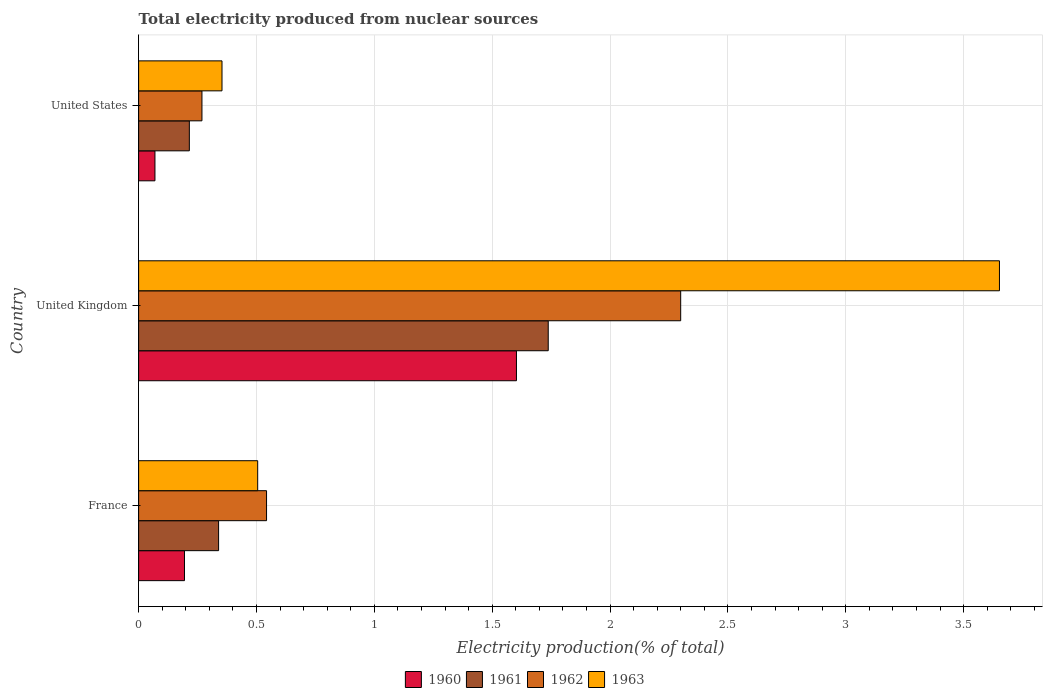Are the number of bars per tick equal to the number of legend labels?
Ensure brevity in your answer.  Yes. Are the number of bars on each tick of the Y-axis equal?
Provide a short and direct response. Yes. How many bars are there on the 3rd tick from the top?
Offer a very short reply. 4. What is the label of the 1st group of bars from the top?
Give a very brief answer. United States. In how many cases, is the number of bars for a given country not equal to the number of legend labels?
Ensure brevity in your answer.  0. What is the total electricity produced in 1962 in United Kingdom?
Give a very brief answer. 2.3. Across all countries, what is the maximum total electricity produced in 1960?
Make the answer very short. 1.6. Across all countries, what is the minimum total electricity produced in 1961?
Your response must be concise. 0.22. In which country was the total electricity produced in 1960 maximum?
Provide a short and direct response. United Kingdom. In which country was the total electricity produced in 1962 minimum?
Offer a very short reply. United States. What is the total total electricity produced in 1962 in the graph?
Give a very brief answer. 3.11. What is the difference between the total electricity produced in 1963 in United Kingdom and that in United States?
Your answer should be very brief. 3.3. What is the difference between the total electricity produced in 1963 in United States and the total electricity produced in 1961 in United Kingdom?
Offer a terse response. -1.38. What is the average total electricity produced in 1961 per country?
Your answer should be compact. 0.76. What is the difference between the total electricity produced in 1960 and total electricity produced in 1962 in France?
Your response must be concise. -0.35. What is the ratio of the total electricity produced in 1963 in France to that in United Kingdom?
Make the answer very short. 0.14. Is the total electricity produced in 1962 in United Kingdom less than that in United States?
Your response must be concise. No. What is the difference between the highest and the second highest total electricity produced in 1963?
Your answer should be compact. 3.15. What is the difference between the highest and the lowest total electricity produced in 1960?
Offer a very short reply. 1.53. Is the sum of the total electricity produced in 1962 in United Kingdom and United States greater than the maximum total electricity produced in 1960 across all countries?
Provide a succinct answer. Yes. Is it the case that in every country, the sum of the total electricity produced in 1961 and total electricity produced in 1962 is greater than the sum of total electricity produced in 1960 and total electricity produced in 1963?
Provide a short and direct response. No. What does the 1st bar from the top in United Kingdom represents?
Ensure brevity in your answer.  1963. Are all the bars in the graph horizontal?
Keep it short and to the point. Yes. How many countries are there in the graph?
Give a very brief answer. 3. What is the difference between two consecutive major ticks on the X-axis?
Your answer should be compact. 0.5. Are the values on the major ticks of X-axis written in scientific E-notation?
Offer a terse response. No. Where does the legend appear in the graph?
Keep it short and to the point. Bottom center. How are the legend labels stacked?
Ensure brevity in your answer.  Horizontal. What is the title of the graph?
Provide a succinct answer. Total electricity produced from nuclear sources. Does "1987" appear as one of the legend labels in the graph?
Offer a terse response. No. What is the label or title of the Y-axis?
Make the answer very short. Country. What is the Electricity production(% of total) of 1960 in France?
Keep it short and to the point. 0.19. What is the Electricity production(% of total) of 1961 in France?
Provide a short and direct response. 0.34. What is the Electricity production(% of total) in 1962 in France?
Your answer should be very brief. 0.54. What is the Electricity production(% of total) in 1963 in France?
Your response must be concise. 0.51. What is the Electricity production(% of total) of 1960 in United Kingdom?
Your answer should be compact. 1.6. What is the Electricity production(% of total) of 1961 in United Kingdom?
Offer a very short reply. 1.74. What is the Electricity production(% of total) of 1962 in United Kingdom?
Give a very brief answer. 2.3. What is the Electricity production(% of total) in 1963 in United Kingdom?
Offer a very short reply. 3.65. What is the Electricity production(% of total) in 1960 in United States?
Your answer should be very brief. 0.07. What is the Electricity production(% of total) in 1961 in United States?
Offer a terse response. 0.22. What is the Electricity production(% of total) in 1962 in United States?
Your response must be concise. 0.27. What is the Electricity production(% of total) of 1963 in United States?
Your answer should be very brief. 0.35. Across all countries, what is the maximum Electricity production(% of total) in 1960?
Ensure brevity in your answer.  1.6. Across all countries, what is the maximum Electricity production(% of total) of 1961?
Your response must be concise. 1.74. Across all countries, what is the maximum Electricity production(% of total) in 1962?
Your answer should be compact. 2.3. Across all countries, what is the maximum Electricity production(% of total) of 1963?
Your answer should be very brief. 3.65. Across all countries, what is the minimum Electricity production(% of total) in 1960?
Your answer should be very brief. 0.07. Across all countries, what is the minimum Electricity production(% of total) of 1961?
Make the answer very short. 0.22. Across all countries, what is the minimum Electricity production(% of total) of 1962?
Ensure brevity in your answer.  0.27. Across all countries, what is the minimum Electricity production(% of total) of 1963?
Offer a terse response. 0.35. What is the total Electricity production(% of total) in 1960 in the graph?
Provide a short and direct response. 1.87. What is the total Electricity production(% of total) in 1961 in the graph?
Offer a terse response. 2.29. What is the total Electricity production(% of total) in 1962 in the graph?
Offer a very short reply. 3.11. What is the total Electricity production(% of total) of 1963 in the graph?
Your answer should be very brief. 4.51. What is the difference between the Electricity production(% of total) of 1960 in France and that in United Kingdom?
Your answer should be compact. -1.41. What is the difference between the Electricity production(% of total) of 1961 in France and that in United Kingdom?
Your response must be concise. -1.4. What is the difference between the Electricity production(% of total) of 1962 in France and that in United Kingdom?
Your answer should be compact. -1.76. What is the difference between the Electricity production(% of total) of 1963 in France and that in United Kingdom?
Offer a terse response. -3.15. What is the difference between the Electricity production(% of total) in 1960 in France and that in United States?
Your answer should be very brief. 0.13. What is the difference between the Electricity production(% of total) of 1961 in France and that in United States?
Make the answer very short. 0.12. What is the difference between the Electricity production(% of total) in 1962 in France and that in United States?
Offer a very short reply. 0.27. What is the difference between the Electricity production(% of total) of 1963 in France and that in United States?
Keep it short and to the point. 0.15. What is the difference between the Electricity production(% of total) of 1960 in United Kingdom and that in United States?
Offer a very short reply. 1.53. What is the difference between the Electricity production(% of total) of 1961 in United Kingdom and that in United States?
Offer a very short reply. 1.52. What is the difference between the Electricity production(% of total) in 1962 in United Kingdom and that in United States?
Offer a terse response. 2.03. What is the difference between the Electricity production(% of total) in 1963 in United Kingdom and that in United States?
Keep it short and to the point. 3.3. What is the difference between the Electricity production(% of total) in 1960 in France and the Electricity production(% of total) in 1961 in United Kingdom?
Provide a short and direct response. -1.54. What is the difference between the Electricity production(% of total) in 1960 in France and the Electricity production(% of total) in 1962 in United Kingdom?
Give a very brief answer. -2.11. What is the difference between the Electricity production(% of total) in 1960 in France and the Electricity production(% of total) in 1963 in United Kingdom?
Your answer should be very brief. -3.46. What is the difference between the Electricity production(% of total) in 1961 in France and the Electricity production(% of total) in 1962 in United Kingdom?
Keep it short and to the point. -1.96. What is the difference between the Electricity production(% of total) in 1961 in France and the Electricity production(% of total) in 1963 in United Kingdom?
Provide a succinct answer. -3.31. What is the difference between the Electricity production(% of total) in 1962 in France and the Electricity production(% of total) in 1963 in United Kingdom?
Keep it short and to the point. -3.11. What is the difference between the Electricity production(% of total) of 1960 in France and the Electricity production(% of total) of 1961 in United States?
Your answer should be compact. -0.02. What is the difference between the Electricity production(% of total) in 1960 in France and the Electricity production(% of total) in 1962 in United States?
Your answer should be compact. -0.07. What is the difference between the Electricity production(% of total) in 1960 in France and the Electricity production(% of total) in 1963 in United States?
Your answer should be compact. -0.16. What is the difference between the Electricity production(% of total) of 1961 in France and the Electricity production(% of total) of 1962 in United States?
Your answer should be compact. 0.07. What is the difference between the Electricity production(% of total) in 1961 in France and the Electricity production(% of total) in 1963 in United States?
Give a very brief answer. -0.01. What is the difference between the Electricity production(% of total) in 1962 in France and the Electricity production(% of total) in 1963 in United States?
Give a very brief answer. 0.19. What is the difference between the Electricity production(% of total) in 1960 in United Kingdom and the Electricity production(% of total) in 1961 in United States?
Your answer should be compact. 1.39. What is the difference between the Electricity production(% of total) in 1960 in United Kingdom and the Electricity production(% of total) in 1962 in United States?
Ensure brevity in your answer.  1.33. What is the difference between the Electricity production(% of total) of 1960 in United Kingdom and the Electricity production(% of total) of 1963 in United States?
Offer a terse response. 1.25. What is the difference between the Electricity production(% of total) in 1961 in United Kingdom and the Electricity production(% of total) in 1962 in United States?
Your response must be concise. 1.47. What is the difference between the Electricity production(% of total) in 1961 in United Kingdom and the Electricity production(% of total) in 1963 in United States?
Keep it short and to the point. 1.38. What is the difference between the Electricity production(% of total) of 1962 in United Kingdom and the Electricity production(% of total) of 1963 in United States?
Provide a succinct answer. 1.95. What is the average Electricity production(% of total) of 1960 per country?
Give a very brief answer. 0.62. What is the average Electricity production(% of total) in 1961 per country?
Keep it short and to the point. 0.76. What is the average Electricity production(% of total) in 1962 per country?
Offer a terse response. 1.04. What is the average Electricity production(% of total) of 1963 per country?
Offer a very short reply. 1.5. What is the difference between the Electricity production(% of total) in 1960 and Electricity production(% of total) in 1961 in France?
Provide a short and direct response. -0.14. What is the difference between the Electricity production(% of total) in 1960 and Electricity production(% of total) in 1962 in France?
Your answer should be very brief. -0.35. What is the difference between the Electricity production(% of total) in 1960 and Electricity production(% of total) in 1963 in France?
Give a very brief answer. -0.31. What is the difference between the Electricity production(% of total) of 1961 and Electricity production(% of total) of 1962 in France?
Provide a short and direct response. -0.2. What is the difference between the Electricity production(% of total) of 1961 and Electricity production(% of total) of 1963 in France?
Provide a short and direct response. -0.17. What is the difference between the Electricity production(% of total) in 1962 and Electricity production(% of total) in 1963 in France?
Your response must be concise. 0.04. What is the difference between the Electricity production(% of total) of 1960 and Electricity production(% of total) of 1961 in United Kingdom?
Make the answer very short. -0.13. What is the difference between the Electricity production(% of total) of 1960 and Electricity production(% of total) of 1962 in United Kingdom?
Give a very brief answer. -0.7. What is the difference between the Electricity production(% of total) of 1960 and Electricity production(% of total) of 1963 in United Kingdom?
Ensure brevity in your answer.  -2.05. What is the difference between the Electricity production(% of total) of 1961 and Electricity production(% of total) of 1962 in United Kingdom?
Provide a succinct answer. -0.56. What is the difference between the Electricity production(% of total) of 1961 and Electricity production(% of total) of 1963 in United Kingdom?
Your answer should be compact. -1.91. What is the difference between the Electricity production(% of total) of 1962 and Electricity production(% of total) of 1963 in United Kingdom?
Offer a very short reply. -1.35. What is the difference between the Electricity production(% of total) in 1960 and Electricity production(% of total) in 1961 in United States?
Ensure brevity in your answer.  -0.15. What is the difference between the Electricity production(% of total) of 1960 and Electricity production(% of total) of 1962 in United States?
Your answer should be very brief. -0.2. What is the difference between the Electricity production(% of total) of 1960 and Electricity production(% of total) of 1963 in United States?
Make the answer very short. -0.28. What is the difference between the Electricity production(% of total) of 1961 and Electricity production(% of total) of 1962 in United States?
Keep it short and to the point. -0.05. What is the difference between the Electricity production(% of total) in 1961 and Electricity production(% of total) in 1963 in United States?
Your answer should be very brief. -0.14. What is the difference between the Electricity production(% of total) of 1962 and Electricity production(% of total) of 1963 in United States?
Your answer should be compact. -0.09. What is the ratio of the Electricity production(% of total) in 1960 in France to that in United Kingdom?
Your answer should be very brief. 0.12. What is the ratio of the Electricity production(% of total) in 1961 in France to that in United Kingdom?
Your answer should be compact. 0.2. What is the ratio of the Electricity production(% of total) of 1962 in France to that in United Kingdom?
Offer a very short reply. 0.24. What is the ratio of the Electricity production(% of total) in 1963 in France to that in United Kingdom?
Give a very brief answer. 0.14. What is the ratio of the Electricity production(% of total) of 1960 in France to that in United States?
Keep it short and to the point. 2.81. What is the ratio of the Electricity production(% of total) of 1961 in France to that in United States?
Offer a terse response. 1.58. What is the ratio of the Electricity production(% of total) of 1962 in France to that in United States?
Give a very brief answer. 2.02. What is the ratio of the Electricity production(% of total) of 1963 in France to that in United States?
Provide a short and direct response. 1.43. What is the ratio of the Electricity production(% of total) of 1960 in United Kingdom to that in United States?
Keep it short and to the point. 23.14. What is the ratio of the Electricity production(% of total) of 1961 in United Kingdom to that in United States?
Provide a succinct answer. 8.08. What is the ratio of the Electricity production(% of total) in 1962 in United Kingdom to that in United States?
Make the answer very short. 8.56. What is the ratio of the Electricity production(% of total) in 1963 in United Kingdom to that in United States?
Keep it short and to the point. 10.32. What is the difference between the highest and the second highest Electricity production(% of total) in 1960?
Provide a succinct answer. 1.41. What is the difference between the highest and the second highest Electricity production(% of total) in 1961?
Offer a very short reply. 1.4. What is the difference between the highest and the second highest Electricity production(% of total) of 1962?
Keep it short and to the point. 1.76. What is the difference between the highest and the second highest Electricity production(% of total) in 1963?
Keep it short and to the point. 3.15. What is the difference between the highest and the lowest Electricity production(% of total) in 1960?
Provide a short and direct response. 1.53. What is the difference between the highest and the lowest Electricity production(% of total) in 1961?
Your answer should be compact. 1.52. What is the difference between the highest and the lowest Electricity production(% of total) of 1962?
Provide a short and direct response. 2.03. What is the difference between the highest and the lowest Electricity production(% of total) of 1963?
Give a very brief answer. 3.3. 